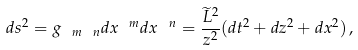Convert formula to latex. <formula><loc_0><loc_0><loc_500><loc_500>d s ^ { 2 } = g _ { \ m \ n } d x ^ { \ m } d x ^ { \ n } = \frac { \widetilde { L } ^ { 2 } } { z ^ { 2 } } ( d t ^ { 2 } + d z ^ { 2 } + d x ^ { 2 } ) \, ,</formula> 